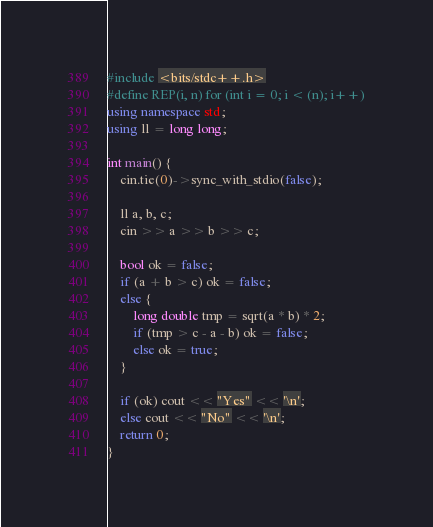Convert code to text. <code><loc_0><loc_0><loc_500><loc_500><_C++_>#include <bits/stdc++.h>
#define REP(i, n) for (int i = 0; i < (n); i++)
using namespace std;
using ll = long long;

int main() {
    cin.tie(0)->sync_with_stdio(false);

    ll a, b, c;
    cin >> a >> b >> c;

    bool ok = false;
    if (a + b > c) ok = false;
    else {
        long double tmp = sqrt(a * b) * 2;
        if (tmp > c - a - b) ok = false;
        else ok = true;
    }

    if (ok) cout << "Yes" << '\n';
    else cout << "No" << '\n';
    return 0;
}</code> 